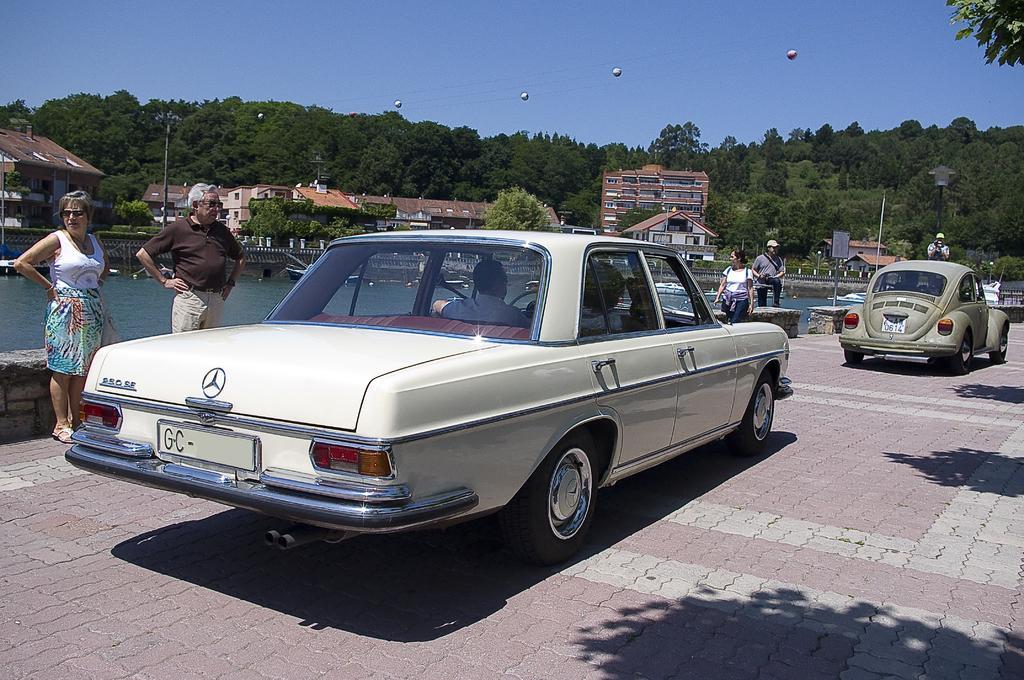Could you give a brief overview of what you see in this image? In this picture we can see some people standing and cars on the road with two people inside a car, boats on water, buildings, poles, trees and some objects and in the background we can see the sky. 